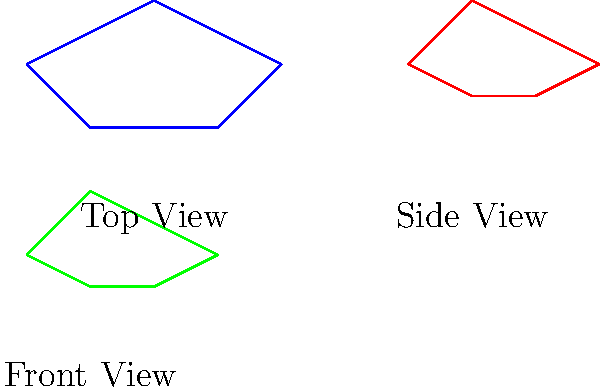In your private military history museum, you're creating an interactive display about aircraft identification. Based on the silhouettes shown in the diagram, which World War II fighter aircraft is being represented from three different angles (top, side, and front views)? To identify the aircraft, let's analyze the silhouettes step-by-step:

1. Top view (blue):
   - Elliptical wing shape
   - Relatively short nose
   - Tapered fuselage

2. Side view (red):
   - Sleek, streamlined profile
   - Elliptical tail fin
   - Bubble canopy

3. Front view (green):
   - Elliptical wing shape visible
   - Narrow fuselage
   - Distinctive radiator intake under the nose

These characteristics are iconic features of the Supermarine Spitfire, a British single-seat fighter aircraft used by the Royal Air Force and other Allied countries during World War II and beyond.

Key identifying features:
- The elliptical wing shape, visible in both top and front views, is the Spitfire's most recognizable feature.
- The streamlined profile and bubble canopy in the side view are typical of later Spitfire models.
- The narrow fuselage and under-nose radiator intake shown in the front view are also distinctive Spitfire characteristics.

The Spitfire was designed by R.J. Mitchell and was instrumental in the Battle of Britain, making it a significant aircraft in military history.
Answer: Supermarine Spitfire 